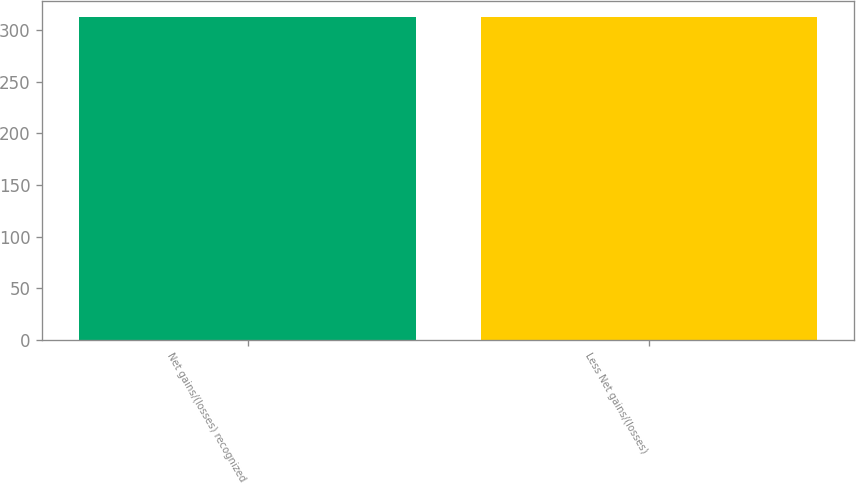<chart> <loc_0><loc_0><loc_500><loc_500><bar_chart><fcel>Net gains/(losses) recognized<fcel>Less Net gains/(losses)<nl><fcel>313<fcel>313.1<nl></chart> 